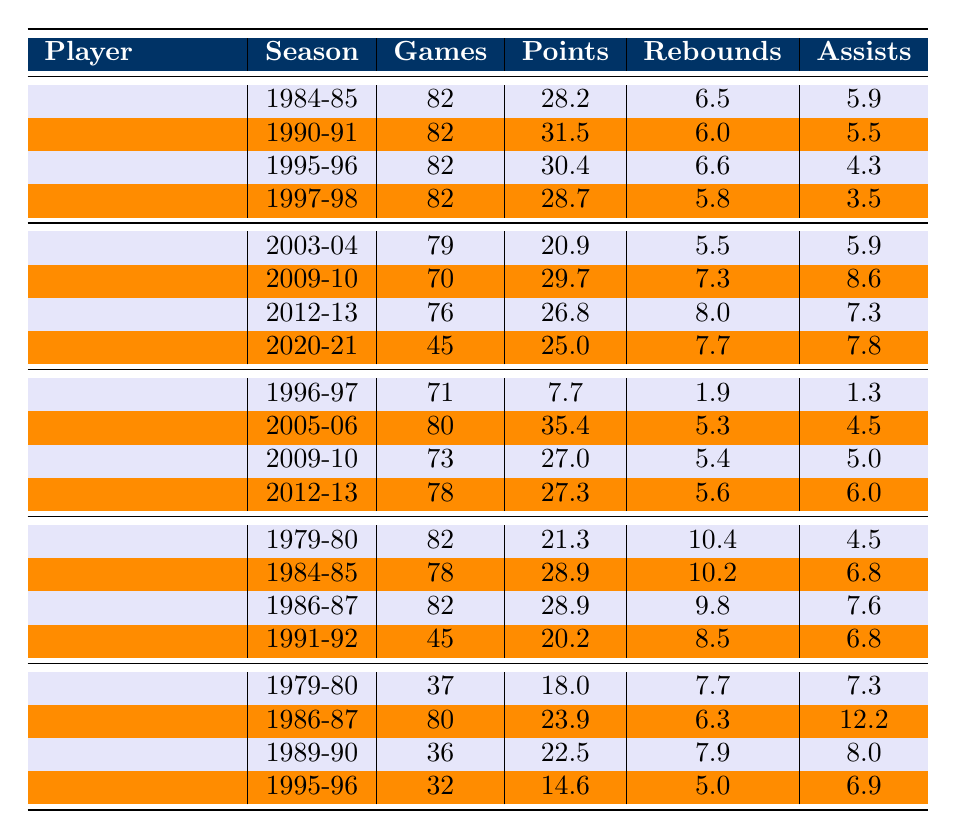What is Michael Jordan's highest points per game in a season? The highest points per game for Michael Jordan is found in the season 1990-91 where he scored 31.5 points.
Answer: 31.5 What season did Kobe Bryant score the most points? Kobe Bryant scored the most points in the season 2005-06 with 35.4 points per game.
Answer: 35.4 Which player had more rebounds on average: Larry Bird or Magic Johnson? First, calculate the average rebounds for Larry Bird: (10.4 + 10.2 + 9.8 + 8.5) / 4 = 9.75. Then, calculate for Magic Johnson: (7.7 + 6.3 + 7.9 + 5.0) / 4 = 6.75. Larry Bird has a higher average.
Answer: Larry Bird What is the total number of games played by LeBron James in the seasons listed? The total games are calculated by summing the games played: 79 + 70 + 76 + 45 = 270.
Answer: 270 Did Michael Jordan ever average less than 28 points per game in a season based on this data? Looking at his seasons, the lowest scoring average was 28.2 in 1984-85. Since all other averages are higher, he did not average less than 28 points.
Answer: No What is the average assists per game for Kobe Bryant in the seasons listed? The assists for Kobe Bryant are: 1.3, 4.5, 5.0, and 6.0. The sum is 17.8, and dividing by the number of seasons (4), gives 17.8 / 4 = 4.45.
Answer: 4.45 In which season did Magic Johnson record the fewest points? By reviewing the points across the seasons, Magic Johnson scored the least in the 1995-96 season with 14.6 points.
Answer: 14.6 Which player had the highest average points across all their listed seasons? Average points for each player are calculated: Michael Jordan = (28.2 + 31.5 + 30.4 + 28.7) / 4 = 29.7, LeBron James = (20.9 + 29.7 + 26.8 + 25.0) / 4 = 25.6, Kobe Bryant = (7.7 + 35.4 + 27.0 + 27.3) / 4 = 24.3, Larry Bird = (21.3 + 28.9 + 28.9 + 20.2) / 4 = 24.83, Magic Johnson = (18.0 + 23.9 + 22.5 + 14.6) / 4 = 19.75. Michael Jordan has the highest average at 29.7 points.
Answer: Michael Jordan What was LeBron James' points per game in the 2012-13 season? In the 2012-13 season, LeBron James scored 26.8 points per game.
Answer: 26.8 Which player's average rebounds per game were higher, Michael Jordan or Kobe Bryant? Michael Jordan's average rebounds: (6.5 + 6.0 + 6.6 + 5.8) / 4 = 6.22; Kobe Bryant's average rebounds: (1.9 + 5.3 + 5.4 + 5.6) / 4 = 4.05. Michael Jordan had a higher average.
Answer: Michael Jordan How many seasons did Larry Bird play based on the data? The data shows four seasons for Larry Bird.
Answer: 4 